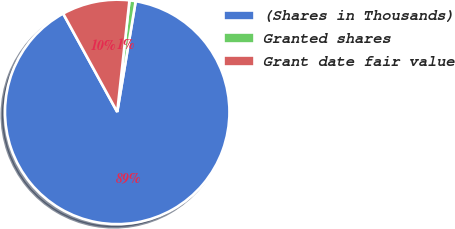Convert chart. <chart><loc_0><loc_0><loc_500><loc_500><pie_chart><fcel>(Shares in Thousands)<fcel>Granted shares<fcel>Grant date fair value<nl><fcel>89.38%<fcel>0.89%<fcel>9.74%<nl></chart> 